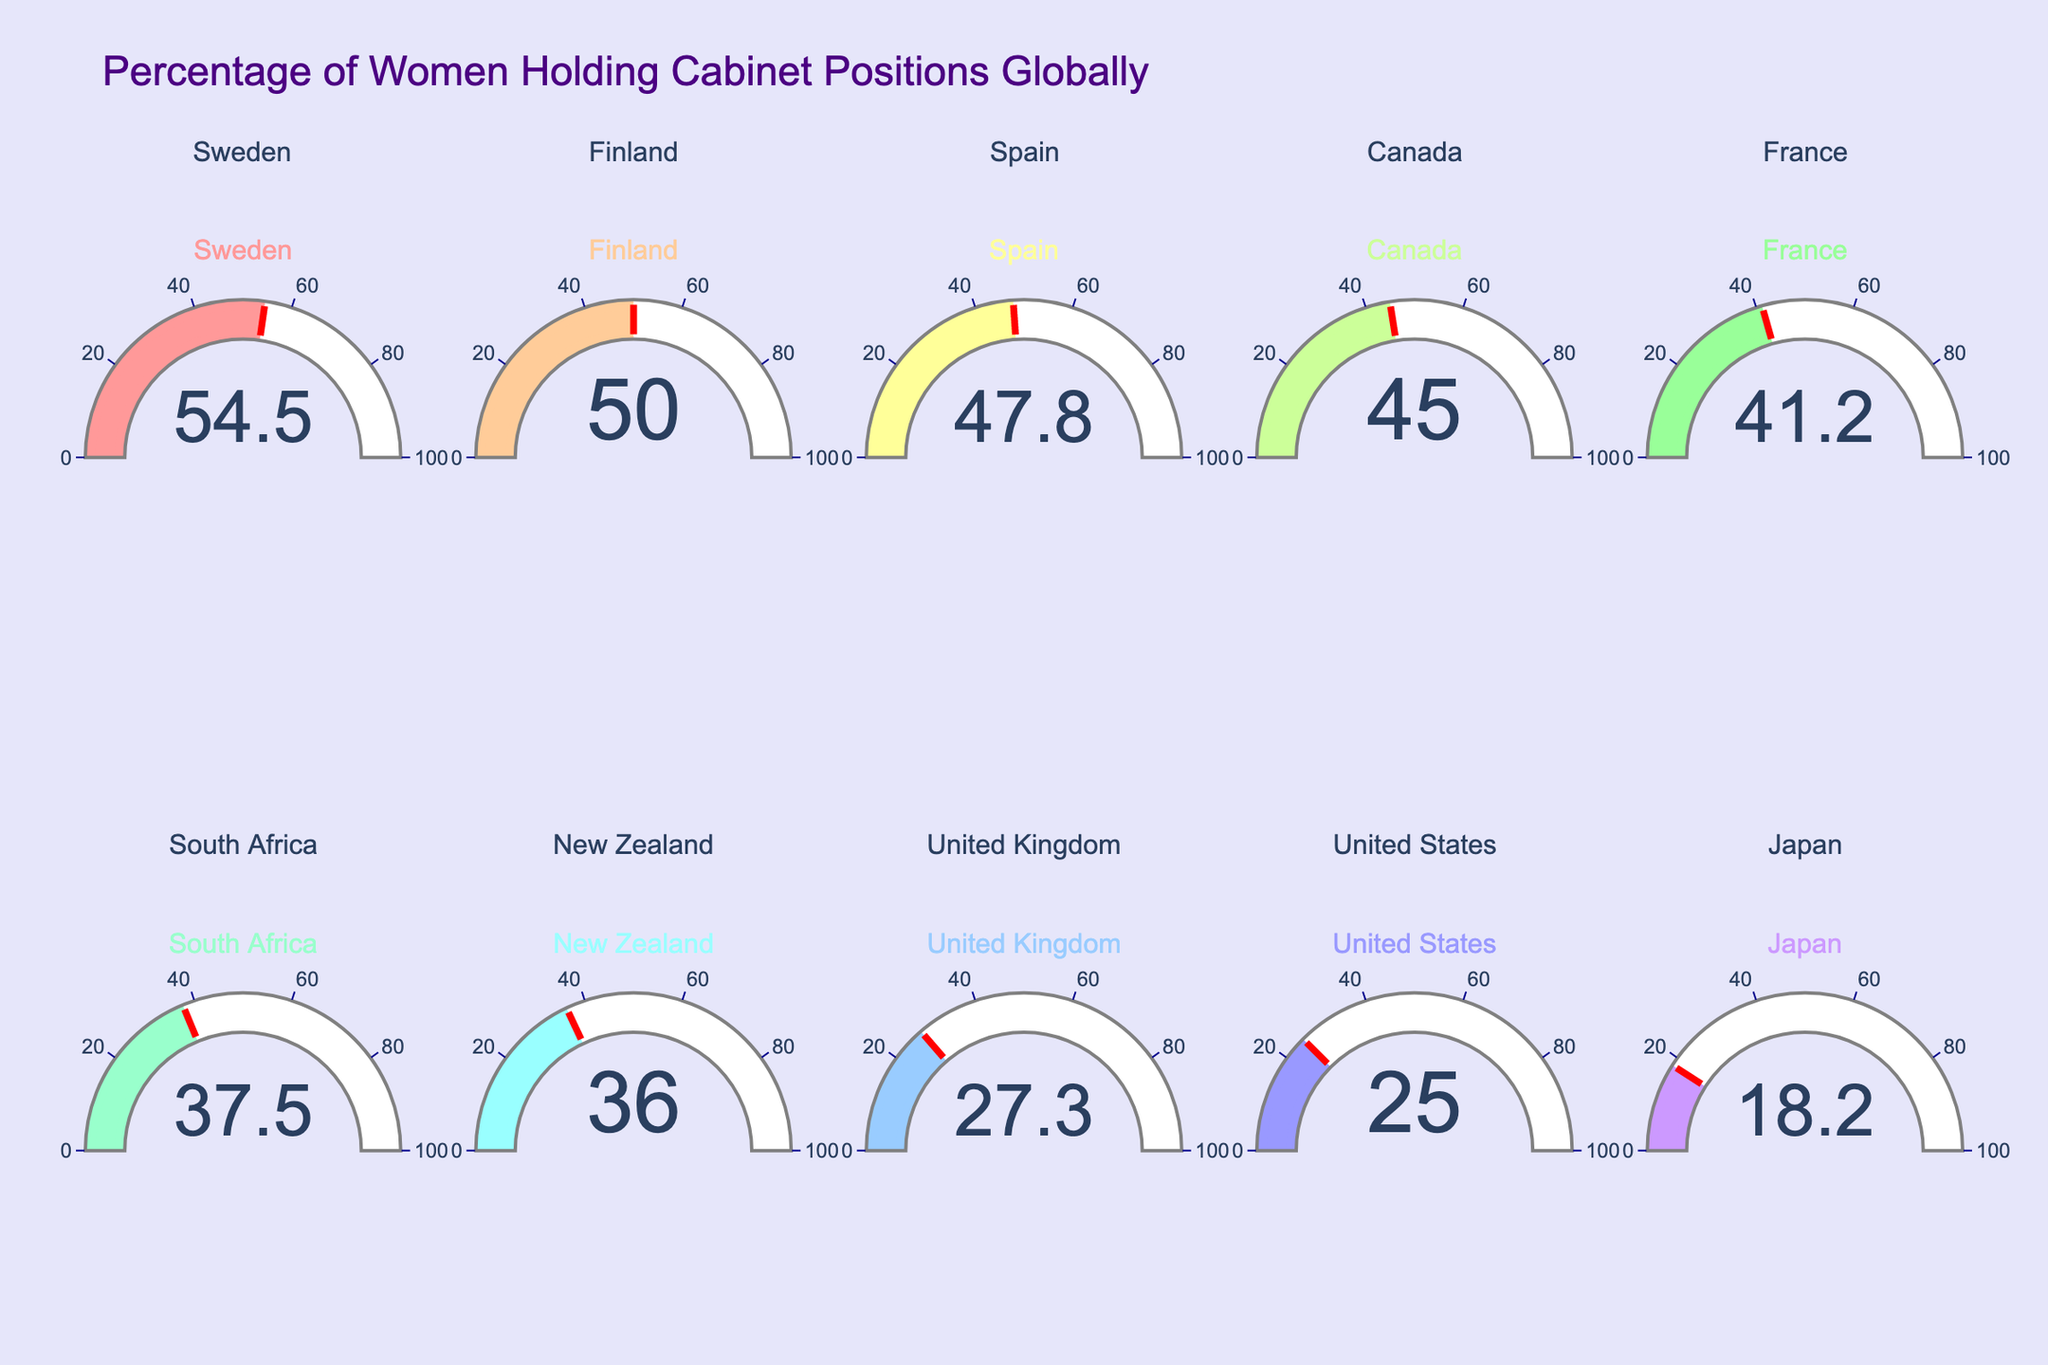Which country has the highest percentage of women holding cabinet positions? The gauge chart shows each country's percentage, and the highest value is for Sweden with a percentage of 54.5%.
Answer: Sweden What is the average percentage of women holding cabinet positions for the countries shown in the figure? Add all the percentages and divide by the number of countries. The total is 54.5 + 50.0 + 47.8 + 45.0 + 41.2 + 37.5 + 36.0 + 27.3 + 25.0 + 18.2 = 382.5%. There are 10 countries. So, the average is 382.5 / 10 = 38.25%.
Answer: 38.25% Which country has the lowest percentage of women holding cabinet positions? The gauge chart shows each country's percentage, and the lowest value is for Japan with a percentage of 18.2%.
Answer: Japan By how much does the percentage of women holding cabinet positions in Finland exceed that of the United States? The percentage for Finland is 50.0%, and for the United States, it is 25.0%. Subtract the US percentage from Finland's: 50.0% - 25.0% = 25.0%.
Answer: 25.0% What is the median percentage of women in cabinet positions among the countries shown? To find the median, list the percentages in order: 18.2, 25.0, 27.3, 36.0, 37.5, 41.2, 45.0, 47.8, 50.0, 54.5. The median is the average of the middle two values: (37.5 + 41.2) / 2 = 39.35%.
Answer: 39.35% Which countries have a percentage of women holding cabinet positions greater than 40%? By examining the gauge chart, the countries with percentages greater than 40% are Sweden (54.5%), Finland (50.0%), Spain (47.8%), Canada (45.0%), and France (41.2%).
Answer: Sweden, Finland, Spain, Canada, France How does the percentage of women in cabinet positions in South Africa compare to that in New Zealand? The percentage for South Africa is 37.5%, and for New Zealand, it is 36.0%. South Africa's percentage is higher by 1.5%.
Answer: South Africa has 1.5% more What is the range of percentages of women holding cabinet positions among the countries shown? The range is calculated as the difference between the highest (Sweden, 54.5%) and the lowest (Japan, 18.2%) percentages: 54.5% - 18.2% = 36.3%.
Answer: 36.3% What is the total percentage of women holding cabinet positions for the top five countries combined? Add the percentages for Sweden, Finland, Spain, Canada, and France: 54.5 + 50.0 + 47.8 + 45.0 + 41.2 = 238.5%.
Answer: 238.5% How many countries have at least 50% women holding cabinet positions? The figure shows that Sweden (54.5%) and Finland (50.0%) have at least 50% women in cabinet positions.
Answer: 2 